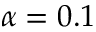Convert formula to latex. <formula><loc_0><loc_0><loc_500><loc_500>\alpha = 0 . 1</formula> 